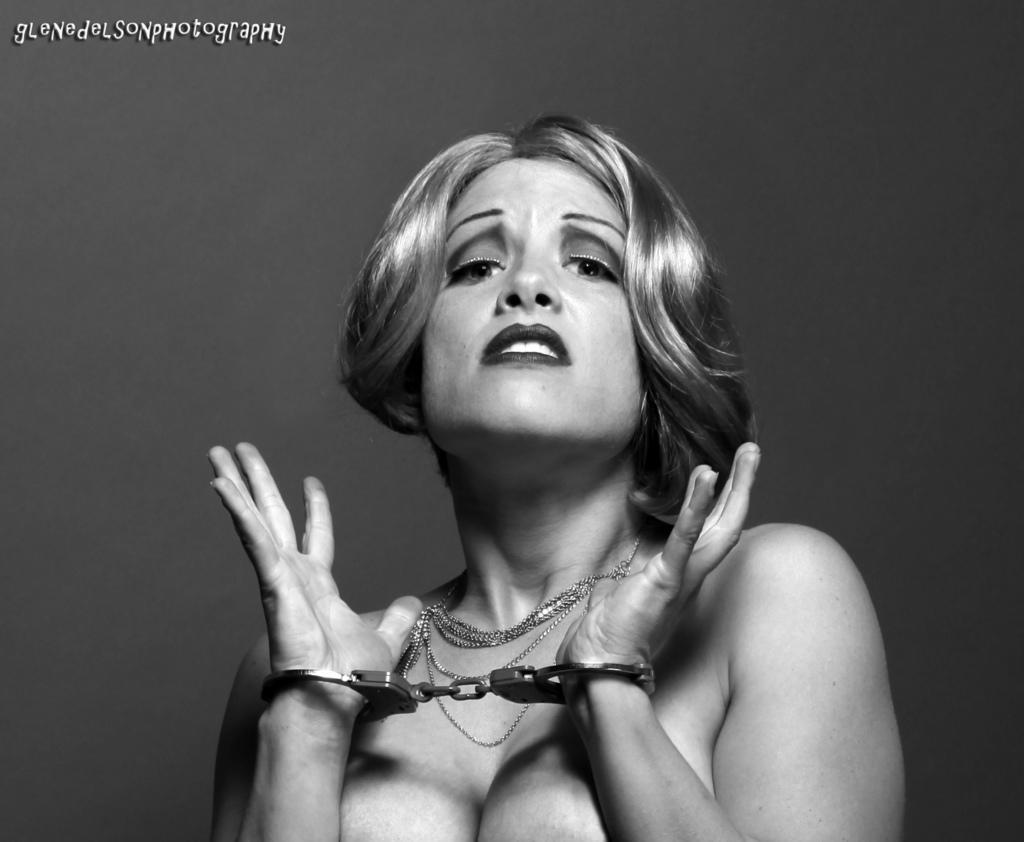Describe this image in one or two sentences. This image consists of a woman. She is having handcuffs. 